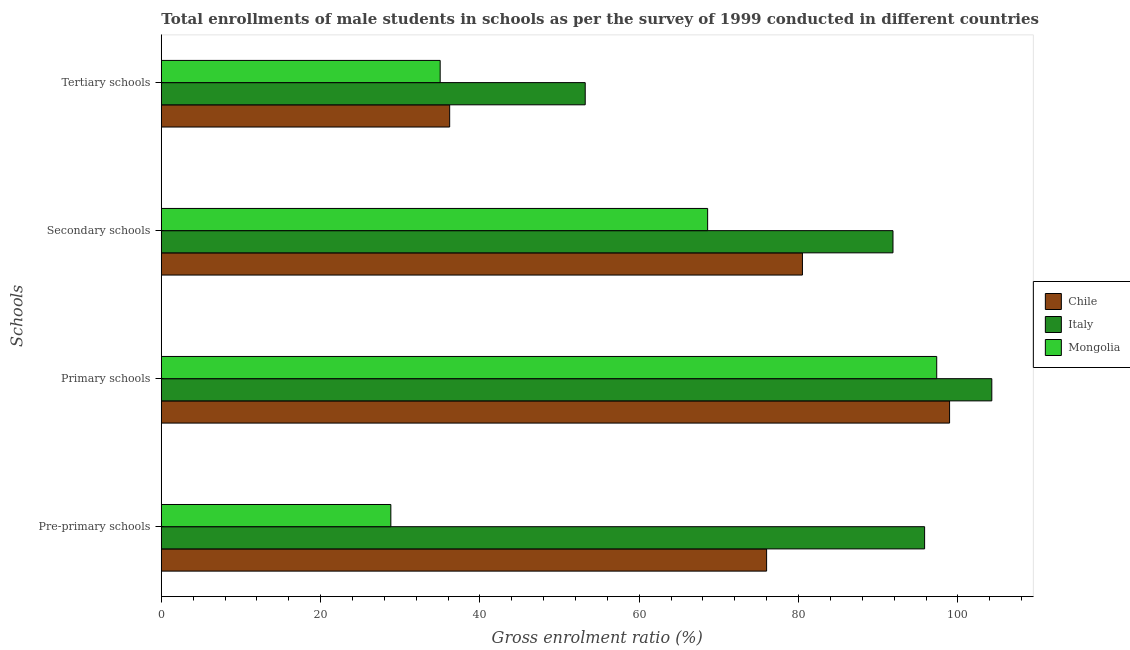How many different coloured bars are there?
Keep it short and to the point. 3. How many groups of bars are there?
Make the answer very short. 4. How many bars are there on the 1st tick from the top?
Provide a short and direct response. 3. What is the label of the 4th group of bars from the top?
Keep it short and to the point. Pre-primary schools. What is the gross enrolment ratio(male) in tertiary schools in Chile?
Offer a terse response. 36.2. Across all countries, what is the maximum gross enrolment ratio(male) in primary schools?
Give a very brief answer. 104.26. Across all countries, what is the minimum gross enrolment ratio(male) in tertiary schools?
Offer a terse response. 35.01. In which country was the gross enrolment ratio(male) in secondary schools minimum?
Give a very brief answer. Mongolia. What is the total gross enrolment ratio(male) in tertiary schools in the graph?
Keep it short and to the point. 124.42. What is the difference between the gross enrolment ratio(male) in secondary schools in Chile and that in Italy?
Offer a very short reply. -11.37. What is the difference between the gross enrolment ratio(male) in primary schools in Italy and the gross enrolment ratio(male) in pre-primary schools in Mongolia?
Your response must be concise. 75.44. What is the average gross enrolment ratio(male) in secondary schools per country?
Ensure brevity in your answer.  80.31. What is the difference between the gross enrolment ratio(male) in tertiary schools and gross enrolment ratio(male) in secondary schools in Mongolia?
Provide a succinct answer. -33.58. In how many countries, is the gross enrolment ratio(male) in primary schools greater than 52 %?
Offer a terse response. 3. What is the ratio of the gross enrolment ratio(male) in tertiary schools in Mongolia to that in Italy?
Make the answer very short. 0.66. What is the difference between the highest and the second highest gross enrolment ratio(male) in pre-primary schools?
Your answer should be very brief. 19.83. What is the difference between the highest and the lowest gross enrolment ratio(male) in pre-primary schools?
Keep it short and to the point. 67.01. Is the sum of the gross enrolment ratio(male) in primary schools in Mongolia and Chile greater than the maximum gross enrolment ratio(male) in tertiary schools across all countries?
Give a very brief answer. Yes. Is it the case that in every country, the sum of the gross enrolment ratio(male) in primary schools and gross enrolment ratio(male) in secondary schools is greater than the sum of gross enrolment ratio(male) in tertiary schools and gross enrolment ratio(male) in pre-primary schools?
Make the answer very short. Yes. Is it the case that in every country, the sum of the gross enrolment ratio(male) in pre-primary schools and gross enrolment ratio(male) in primary schools is greater than the gross enrolment ratio(male) in secondary schools?
Provide a short and direct response. Yes. How many countries are there in the graph?
Provide a short and direct response. 3. Are the values on the major ticks of X-axis written in scientific E-notation?
Your response must be concise. No. Does the graph contain grids?
Offer a terse response. No. Where does the legend appear in the graph?
Your response must be concise. Center right. How many legend labels are there?
Your answer should be compact. 3. What is the title of the graph?
Provide a succinct answer. Total enrollments of male students in schools as per the survey of 1999 conducted in different countries. Does "Slovak Republic" appear as one of the legend labels in the graph?
Your answer should be very brief. No. What is the label or title of the Y-axis?
Give a very brief answer. Schools. What is the Gross enrolment ratio (%) of Chile in Pre-primary schools?
Your response must be concise. 75.99. What is the Gross enrolment ratio (%) of Italy in Pre-primary schools?
Provide a short and direct response. 95.82. What is the Gross enrolment ratio (%) in Mongolia in Pre-primary schools?
Provide a succinct answer. 28.82. What is the Gross enrolment ratio (%) in Chile in Primary schools?
Give a very brief answer. 98.96. What is the Gross enrolment ratio (%) of Italy in Primary schools?
Give a very brief answer. 104.26. What is the Gross enrolment ratio (%) in Mongolia in Primary schools?
Provide a succinct answer. 97.34. What is the Gross enrolment ratio (%) in Chile in Secondary schools?
Your answer should be compact. 80.49. What is the Gross enrolment ratio (%) in Italy in Secondary schools?
Your answer should be compact. 91.85. What is the Gross enrolment ratio (%) of Mongolia in Secondary schools?
Provide a succinct answer. 68.59. What is the Gross enrolment ratio (%) of Chile in Tertiary schools?
Ensure brevity in your answer.  36.2. What is the Gross enrolment ratio (%) in Italy in Tertiary schools?
Make the answer very short. 53.22. What is the Gross enrolment ratio (%) of Mongolia in Tertiary schools?
Offer a very short reply. 35.01. Across all Schools, what is the maximum Gross enrolment ratio (%) in Chile?
Your response must be concise. 98.96. Across all Schools, what is the maximum Gross enrolment ratio (%) in Italy?
Your answer should be very brief. 104.26. Across all Schools, what is the maximum Gross enrolment ratio (%) in Mongolia?
Your response must be concise. 97.34. Across all Schools, what is the minimum Gross enrolment ratio (%) in Chile?
Give a very brief answer. 36.2. Across all Schools, what is the minimum Gross enrolment ratio (%) in Italy?
Your response must be concise. 53.22. Across all Schools, what is the minimum Gross enrolment ratio (%) of Mongolia?
Offer a terse response. 28.82. What is the total Gross enrolment ratio (%) in Chile in the graph?
Give a very brief answer. 291.63. What is the total Gross enrolment ratio (%) of Italy in the graph?
Make the answer very short. 345.15. What is the total Gross enrolment ratio (%) of Mongolia in the graph?
Give a very brief answer. 229.75. What is the difference between the Gross enrolment ratio (%) in Chile in Pre-primary schools and that in Primary schools?
Provide a succinct answer. -22.97. What is the difference between the Gross enrolment ratio (%) of Italy in Pre-primary schools and that in Primary schools?
Your answer should be compact. -8.44. What is the difference between the Gross enrolment ratio (%) in Mongolia in Pre-primary schools and that in Primary schools?
Provide a short and direct response. -68.53. What is the difference between the Gross enrolment ratio (%) of Chile in Pre-primary schools and that in Secondary schools?
Make the answer very short. -4.5. What is the difference between the Gross enrolment ratio (%) in Italy in Pre-primary schools and that in Secondary schools?
Offer a very short reply. 3.97. What is the difference between the Gross enrolment ratio (%) of Mongolia in Pre-primary schools and that in Secondary schools?
Make the answer very short. -39.77. What is the difference between the Gross enrolment ratio (%) in Chile in Pre-primary schools and that in Tertiary schools?
Make the answer very short. 39.79. What is the difference between the Gross enrolment ratio (%) of Italy in Pre-primary schools and that in Tertiary schools?
Ensure brevity in your answer.  42.61. What is the difference between the Gross enrolment ratio (%) of Mongolia in Pre-primary schools and that in Tertiary schools?
Offer a very short reply. -6.19. What is the difference between the Gross enrolment ratio (%) of Chile in Primary schools and that in Secondary schools?
Ensure brevity in your answer.  18.47. What is the difference between the Gross enrolment ratio (%) in Italy in Primary schools and that in Secondary schools?
Keep it short and to the point. 12.41. What is the difference between the Gross enrolment ratio (%) in Mongolia in Primary schools and that in Secondary schools?
Ensure brevity in your answer.  28.76. What is the difference between the Gross enrolment ratio (%) of Chile in Primary schools and that in Tertiary schools?
Ensure brevity in your answer.  62.76. What is the difference between the Gross enrolment ratio (%) in Italy in Primary schools and that in Tertiary schools?
Give a very brief answer. 51.04. What is the difference between the Gross enrolment ratio (%) in Mongolia in Primary schools and that in Tertiary schools?
Provide a short and direct response. 62.34. What is the difference between the Gross enrolment ratio (%) of Chile in Secondary schools and that in Tertiary schools?
Keep it short and to the point. 44.29. What is the difference between the Gross enrolment ratio (%) of Italy in Secondary schools and that in Tertiary schools?
Make the answer very short. 38.64. What is the difference between the Gross enrolment ratio (%) of Mongolia in Secondary schools and that in Tertiary schools?
Keep it short and to the point. 33.58. What is the difference between the Gross enrolment ratio (%) of Chile in Pre-primary schools and the Gross enrolment ratio (%) of Italy in Primary schools?
Keep it short and to the point. -28.27. What is the difference between the Gross enrolment ratio (%) in Chile in Pre-primary schools and the Gross enrolment ratio (%) in Mongolia in Primary schools?
Your answer should be very brief. -21.36. What is the difference between the Gross enrolment ratio (%) in Italy in Pre-primary schools and the Gross enrolment ratio (%) in Mongolia in Primary schools?
Your answer should be compact. -1.52. What is the difference between the Gross enrolment ratio (%) of Chile in Pre-primary schools and the Gross enrolment ratio (%) of Italy in Secondary schools?
Ensure brevity in your answer.  -15.86. What is the difference between the Gross enrolment ratio (%) in Chile in Pre-primary schools and the Gross enrolment ratio (%) in Mongolia in Secondary schools?
Ensure brevity in your answer.  7.4. What is the difference between the Gross enrolment ratio (%) of Italy in Pre-primary schools and the Gross enrolment ratio (%) of Mongolia in Secondary schools?
Your answer should be very brief. 27.24. What is the difference between the Gross enrolment ratio (%) of Chile in Pre-primary schools and the Gross enrolment ratio (%) of Italy in Tertiary schools?
Your answer should be compact. 22.77. What is the difference between the Gross enrolment ratio (%) in Chile in Pre-primary schools and the Gross enrolment ratio (%) in Mongolia in Tertiary schools?
Provide a short and direct response. 40.98. What is the difference between the Gross enrolment ratio (%) of Italy in Pre-primary schools and the Gross enrolment ratio (%) of Mongolia in Tertiary schools?
Your answer should be compact. 60.82. What is the difference between the Gross enrolment ratio (%) of Chile in Primary schools and the Gross enrolment ratio (%) of Italy in Secondary schools?
Offer a terse response. 7.1. What is the difference between the Gross enrolment ratio (%) of Chile in Primary schools and the Gross enrolment ratio (%) of Mongolia in Secondary schools?
Provide a succinct answer. 30.37. What is the difference between the Gross enrolment ratio (%) of Italy in Primary schools and the Gross enrolment ratio (%) of Mongolia in Secondary schools?
Provide a succinct answer. 35.67. What is the difference between the Gross enrolment ratio (%) of Chile in Primary schools and the Gross enrolment ratio (%) of Italy in Tertiary schools?
Your response must be concise. 45.74. What is the difference between the Gross enrolment ratio (%) in Chile in Primary schools and the Gross enrolment ratio (%) in Mongolia in Tertiary schools?
Your answer should be compact. 63.95. What is the difference between the Gross enrolment ratio (%) in Italy in Primary schools and the Gross enrolment ratio (%) in Mongolia in Tertiary schools?
Give a very brief answer. 69.25. What is the difference between the Gross enrolment ratio (%) of Chile in Secondary schools and the Gross enrolment ratio (%) of Italy in Tertiary schools?
Your response must be concise. 27.27. What is the difference between the Gross enrolment ratio (%) of Chile in Secondary schools and the Gross enrolment ratio (%) of Mongolia in Tertiary schools?
Provide a succinct answer. 45.48. What is the difference between the Gross enrolment ratio (%) in Italy in Secondary schools and the Gross enrolment ratio (%) in Mongolia in Tertiary schools?
Offer a very short reply. 56.85. What is the average Gross enrolment ratio (%) in Chile per Schools?
Offer a terse response. 72.91. What is the average Gross enrolment ratio (%) in Italy per Schools?
Your response must be concise. 86.29. What is the average Gross enrolment ratio (%) of Mongolia per Schools?
Provide a succinct answer. 57.44. What is the difference between the Gross enrolment ratio (%) in Chile and Gross enrolment ratio (%) in Italy in Pre-primary schools?
Your answer should be very brief. -19.83. What is the difference between the Gross enrolment ratio (%) of Chile and Gross enrolment ratio (%) of Mongolia in Pre-primary schools?
Provide a succinct answer. 47.17. What is the difference between the Gross enrolment ratio (%) in Italy and Gross enrolment ratio (%) in Mongolia in Pre-primary schools?
Offer a very short reply. 67.01. What is the difference between the Gross enrolment ratio (%) in Chile and Gross enrolment ratio (%) in Italy in Primary schools?
Keep it short and to the point. -5.3. What is the difference between the Gross enrolment ratio (%) in Chile and Gross enrolment ratio (%) in Mongolia in Primary schools?
Make the answer very short. 1.61. What is the difference between the Gross enrolment ratio (%) in Italy and Gross enrolment ratio (%) in Mongolia in Primary schools?
Ensure brevity in your answer.  6.92. What is the difference between the Gross enrolment ratio (%) of Chile and Gross enrolment ratio (%) of Italy in Secondary schools?
Give a very brief answer. -11.37. What is the difference between the Gross enrolment ratio (%) of Chile and Gross enrolment ratio (%) of Mongolia in Secondary schools?
Ensure brevity in your answer.  11.9. What is the difference between the Gross enrolment ratio (%) of Italy and Gross enrolment ratio (%) of Mongolia in Secondary schools?
Provide a succinct answer. 23.27. What is the difference between the Gross enrolment ratio (%) in Chile and Gross enrolment ratio (%) in Italy in Tertiary schools?
Offer a terse response. -17.02. What is the difference between the Gross enrolment ratio (%) in Chile and Gross enrolment ratio (%) in Mongolia in Tertiary schools?
Provide a short and direct response. 1.19. What is the difference between the Gross enrolment ratio (%) in Italy and Gross enrolment ratio (%) in Mongolia in Tertiary schools?
Ensure brevity in your answer.  18.21. What is the ratio of the Gross enrolment ratio (%) in Chile in Pre-primary schools to that in Primary schools?
Give a very brief answer. 0.77. What is the ratio of the Gross enrolment ratio (%) in Italy in Pre-primary schools to that in Primary schools?
Make the answer very short. 0.92. What is the ratio of the Gross enrolment ratio (%) of Mongolia in Pre-primary schools to that in Primary schools?
Ensure brevity in your answer.  0.3. What is the ratio of the Gross enrolment ratio (%) of Chile in Pre-primary schools to that in Secondary schools?
Provide a short and direct response. 0.94. What is the ratio of the Gross enrolment ratio (%) of Italy in Pre-primary schools to that in Secondary schools?
Offer a very short reply. 1.04. What is the ratio of the Gross enrolment ratio (%) of Mongolia in Pre-primary schools to that in Secondary schools?
Give a very brief answer. 0.42. What is the ratio of the Gross enrolment ratio (%) in Chile in Pre-primary schools to that in Tertiary schools?
Ensure brevity in your answer.  2.1. What is the ratio of the Gross enrolment ratio (%) in Italy in Pre-primary schools to that in Tertiary schools?
Provide a short and direct response. 1.8. What is the ratio of the Gross enrolment ratio (%) in Mongolia in Pre-primary schools to that in Tertiary schools?
Offer a very short reply. 0.82. What is the ratio of the Gross enrolment ratio (%) of Chile in Primary schools to that in Secondary schools?
Ensure brevity in your answer.  1.23. What is the ratio of the Gross enrolment ratio (%) in Italy in Primary schools to that in Secondary schools?
Ensure brevity in your answer.  1.14. What is the ratio of the Gross enrolment ratio (%) of Mongolia in Primary schools to that in Secondary schools?
Offer a very short reply. 1.42. What is the ratio of the Gross enrolment ratio (%) in Chile in Primary schools to that in Tertiary schools?
Ensure brevity in your answer.  2.73. What is the ratio of the Gross enrolment ratio (%) of Italy in Primary schools to that in Tertiary schools?
Provide a short and direct response. 1.96. What is the ratio of the Gross enrolment ratio (%) of Mongolia in Primary schools to that in Tertiary schools?
Offer a terse response. 2.78. What is the ratio of the Gross enrolment ratio (%) in Chile in Secondary schools to that in Tertiary schools?
Your response must be concise. 2.22. What is the ratio of the Gross enrolment ratio (%) in Italy in Secondary schools to that in Tertiary schools?
Your answer should be very brief. 1.73. What is the ratio of the Gross enrolment ratio (%) in Mongolia in Secondary schools to that in Tertiary schools?
Your answer should be compact. 1.96. What is the difference between the highest and the second highest Gross enrolment ratio (%) of Chile?
Offer a very short reply. 18.47. What is the difference between the highest and the second highest Gross enrolment ratio (%) of Italy?
Your response must be concise. 8.44. What is the difference between the highest and the second highest Gross enrolment ratio (%) in Mongolia?
Keep it short and to the point. 28.76. What is the difference between the highest and the lowest Gross enrolment ratio (%) of Chile?
Your response must be concise. 62.76. What is the difference between the highest and the lowest Gross enrolment ratio (%) of Italy?
Ensure brevity in your answer.  51.04. What is the difference between the highest and the lowest Gross enrolment ratio (%) of Mongolia?
Provide a short and direct response. 68.53. 